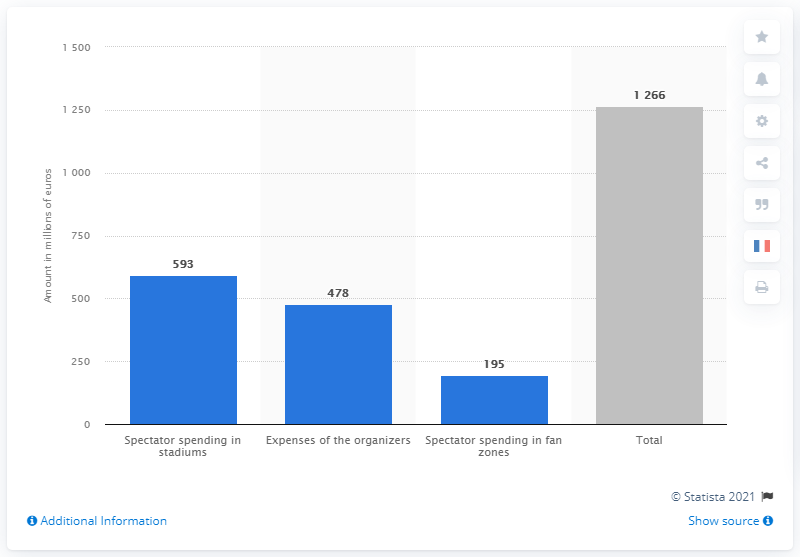Mention a couple of crucial points in this snapshot. The average of the first three blue bars is 422. The first blue bar from left to right has a value of 593. 